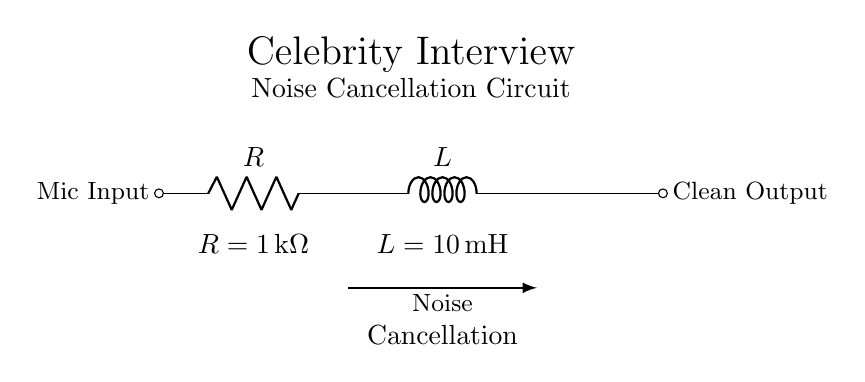What is the resistance value in the circuit? The circuit diagram shows a resistor labeled with a value of 1 kΩ. By locating the component symbol for the resistor, we can directly read its value from the notation provided.
Answer: 1 kΩ What is the inductance value in the circuit? The inductance value for the inductor in the circuit is indicated as 10 mH. This information is found next to the inductor symbol in the diagram, making it straightforward to identify.
Answer: 10 mH How many components are in the circuit? The circuit consists of two components: one resistor and one inductor. By counting these components, it is evident that the total is two.
Answer: 2 What is the purpose of the noise cancellation label in the circuit? The noise cancellation label indicates the function of the resistor-inductor circuit, which is to minimize unwanted noise in the microphone output. This is suggested by its placement in the diagram, showing that it processes the mic input to achieve a cleaner output.
Answer: Noise cancellation What is the current direction through the circuit? The circuit diagram does not show explicit current direction; however, the assumed current flows from left to right, entering the resistor first, followed by the inductor, indicating the typical flow in such configurations.
Answer: Left to right Why is an inductor used in the circuit design? An inductor is employed in this circuit for its ability to oppose changes in current and thus filter out high-frequency noise. This is important in microphone applications to ensure a cleaner audio signal is produced. The inductor's behavior when combined with the resistor improves the circuit’s noise cancellation capability, making it highly suitable for the intended purpose.
Answer: To filter noise What type of circuit configuration is shown in the diagram? The configuration illustrated in the diagram is a series circuit, as the resistor and inductor are connected end-to-end, allowing the same current to pass through both components sequentially. This is identifiable by the direct connection from one to another without any branching.
Answer: Series circuit 